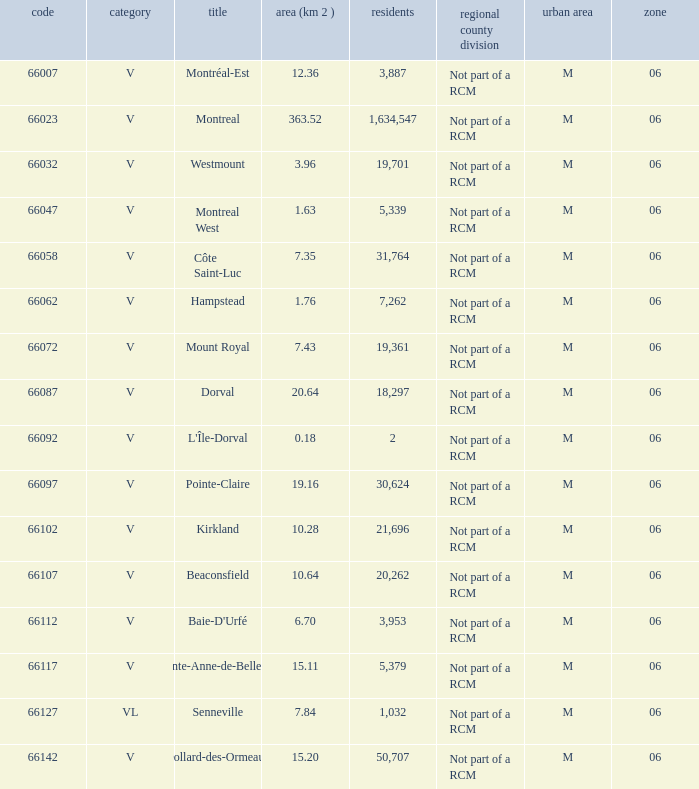What is the largest area with a Code of 66097, and a Region larger than 6? None. 